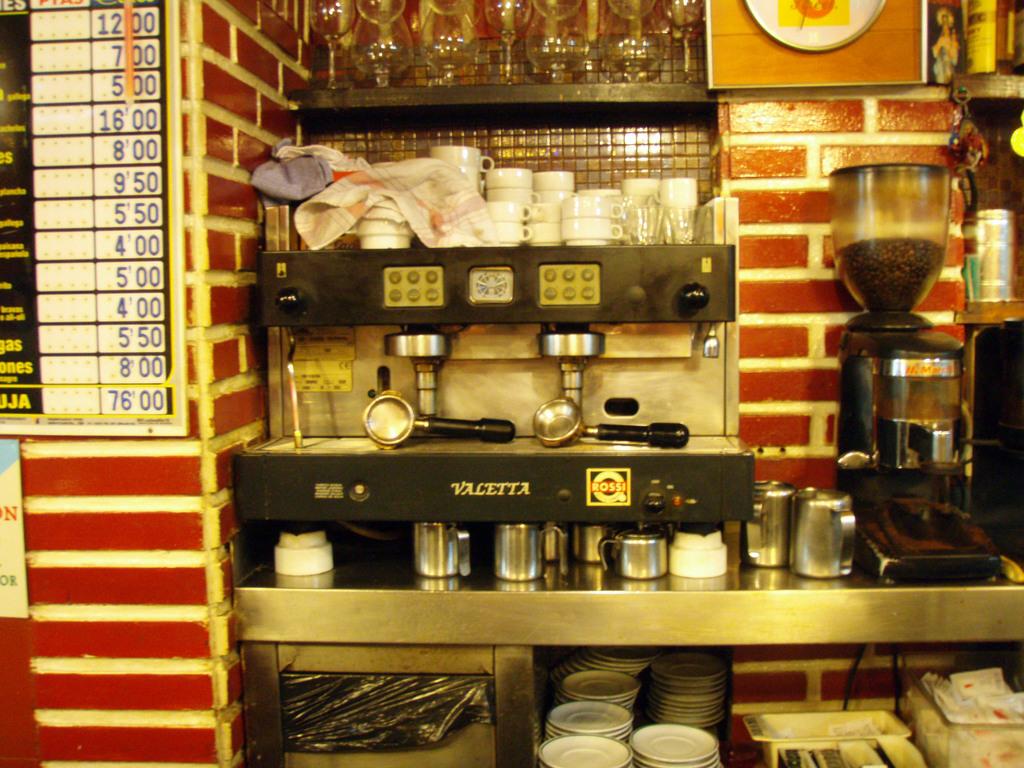What brand is the coffee machine?
Provide a short and direct response. Valetta. What is the biggest amount on the right sign below 8.00?
Make the answer very short. 76.00. 